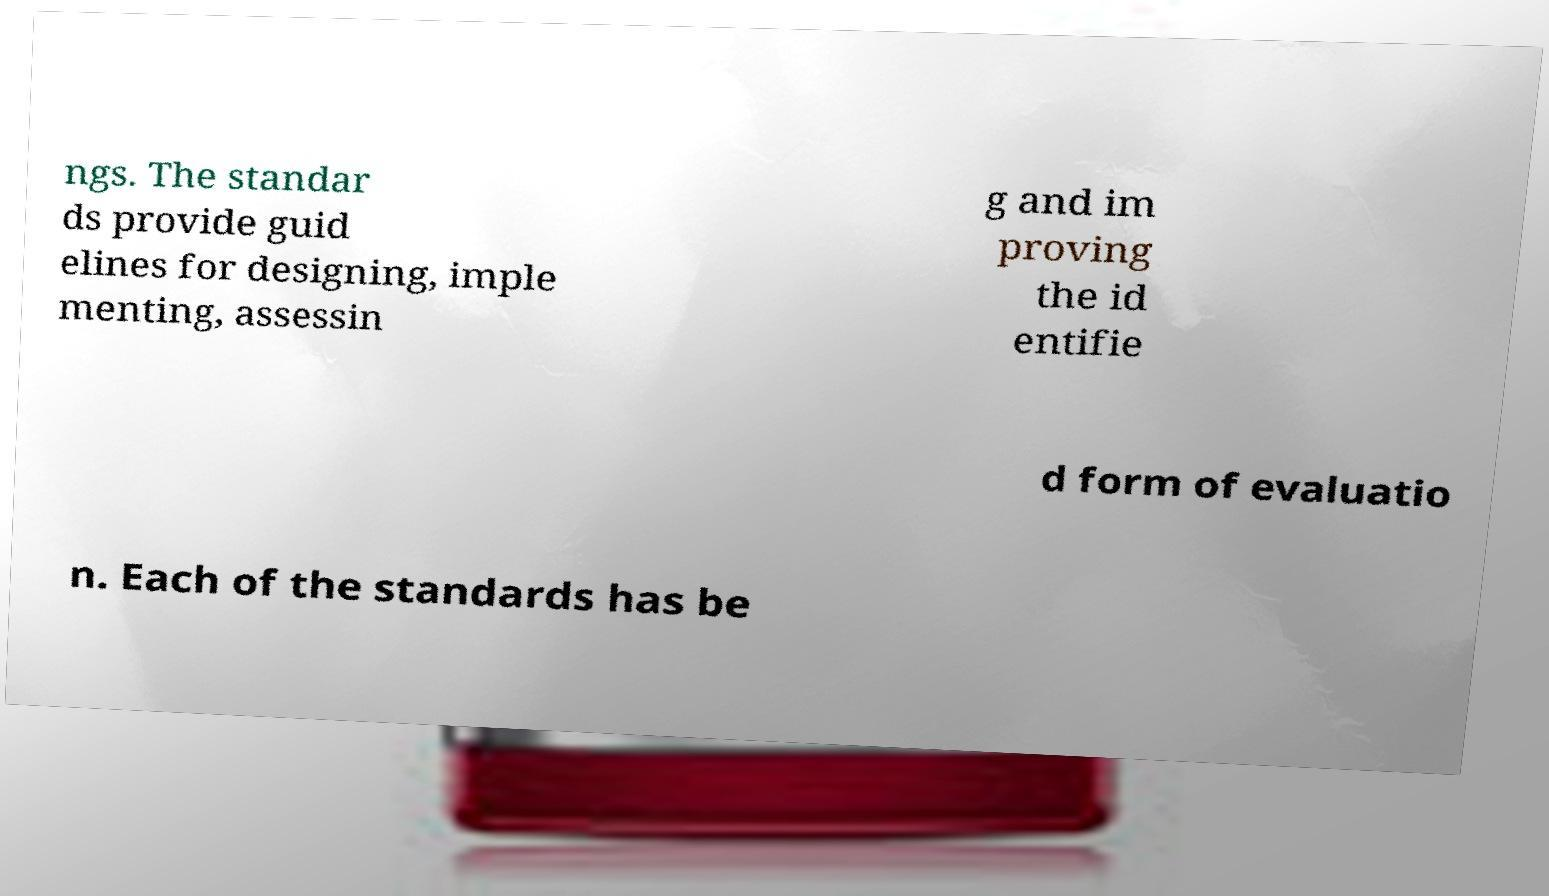Could you extract and type out the text from this image? ngs. The standar ds provide guid elines for designing, imple menting, assessin g and im proving the id entifie d form of evaluatio n. Each of the standards has be 